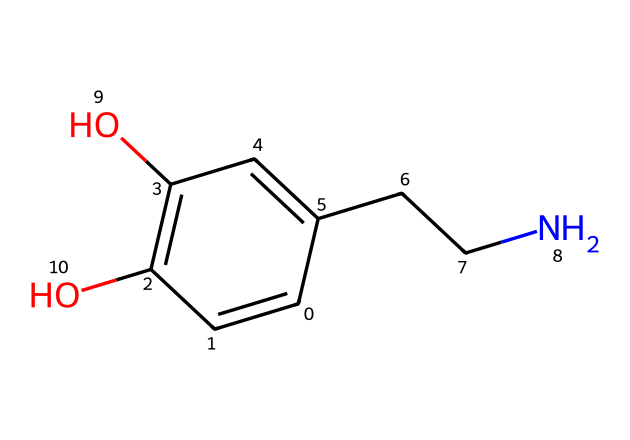What is the main functional group present in this molecular structure? The chemical structure contains hydroxyl groups (–OH), which are visible as the two –OH groups attached to the aromatic ring. These functional groups are indicative of its classification as a phenolic compound.
Answer: hydroxyl How many carbon atoms are in this molecule? By analyzing the SMILES representation, we can count the number of carbon atoms; the structure indicates there are a total of 9 carbon atoms present in this compound.
Answer: 9 What type of neurotransmitter is represented by this chemical? This chemical corresponds to dopamine, which is classified as a neurotransmitter responsible for feelings of pleasure and reward, particularly during events like award wins.
Answer: neurotransmitter What kind of relationship do the nitrogen and carbon atoms have in this molecule? The nitrogen atom is connected to a carbon chain (CCN) indicating that it is part of an amine functional group which connects the nitrogen to the aromatic ring through a two-carbon linker, thus representing a secondary amine.
Answer: secondary amine How many oxygen atoms are present in this compound? Analyzing the structure reveals that there are 2 oxygen atoms in the molecule, both part of the hydroxyl functional groups attached to the aromatic ring.
Answer: 2 What is the significance of the double bonds in this chemical structure? The double bonds between certain carbon atoms indicate unsaturation, which affects the chemical reactivity and stability of the compound, as well as its interaction with receptors in the brain.
Answer: unsaturation 